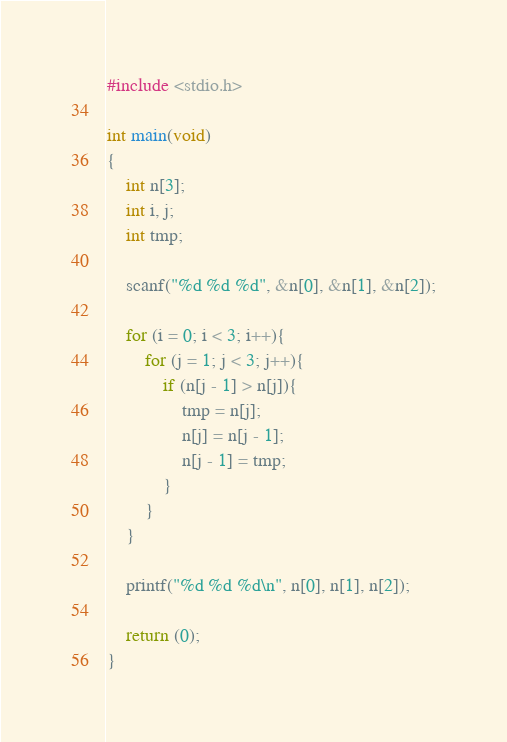<code> <loc_0><loc_0><loc_500><loc_500><_C_>#include <stdio.h>

int main(void)
{
	int n[3];
	int i, j;
	int tmp;
	
	scanf("%d %d %d", &n[0], &n[1], &n[2]);
	
	for (i = 0; i < 3; i++){
		for (j = 1; j < 3; j++){
			if (n[j - 1] > n[j]){
				tmp = n[j];
				n[j] = n[j - 1];
				n[j - 1] = tmp;
			}
		}
	}
	
	printf("%d %d %d\n", n[0], n[1], n[2]);
	
	return (0);
}</code> 